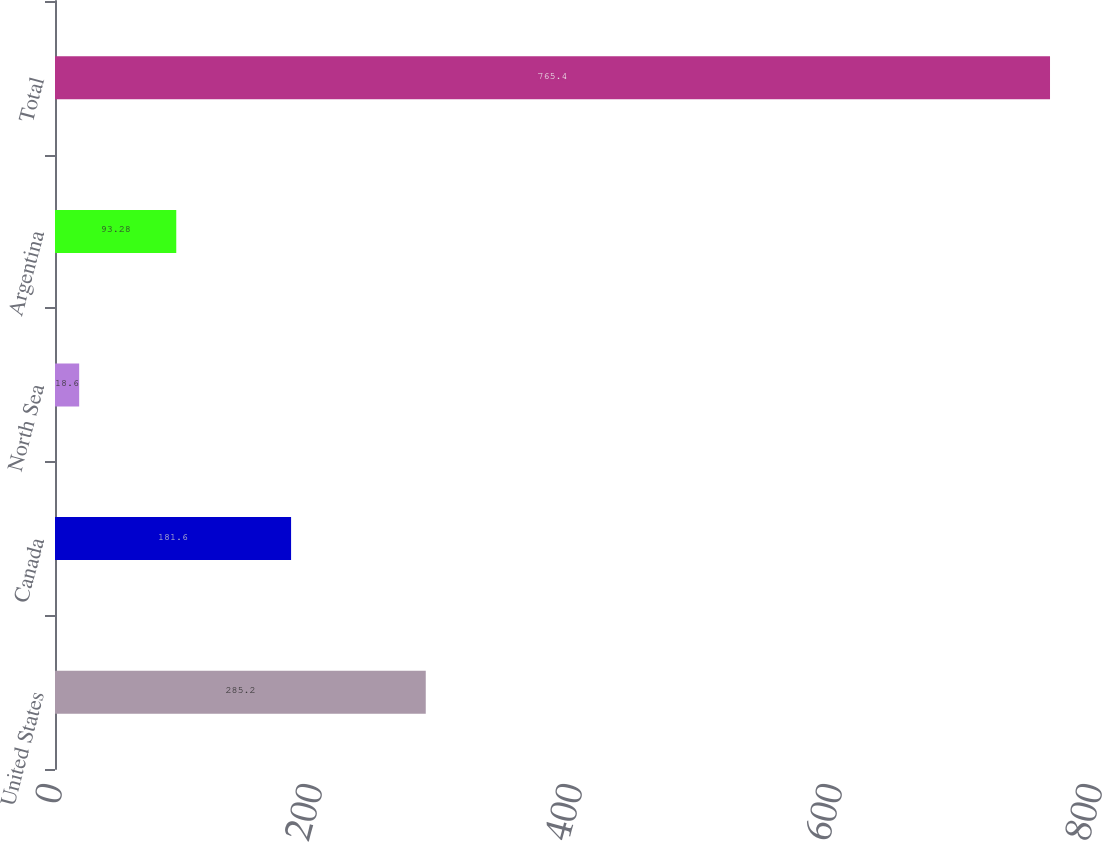Convert chart to OTSL. <chart><loc_0><loc_0><loc_500><loc_500><bar_chart><fcel>United States<fcel>Canada<fcel>North Sea<fcel>Argentina<fcel>Total<nl><fcel>285.2<fcel>181.6<fcel>18.6<fcel>93.28<fcel>765.4<nl></chart> 